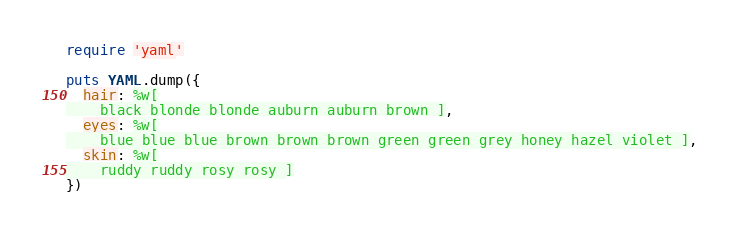Convert code to text. <code><loc_0><loc_0><loc_500><loc_500><_Ruby_>
require 'yaml'

puts YAML.dump({
  hair: %w[
    black blonde blonde auburn auburn brown ],
  eyes: %w[
    blue blue blue brown brown brown green green grey honey hazel violet ],
  skin: %w[
    ruddy ruddy rosy rosy ]
})

</code> 